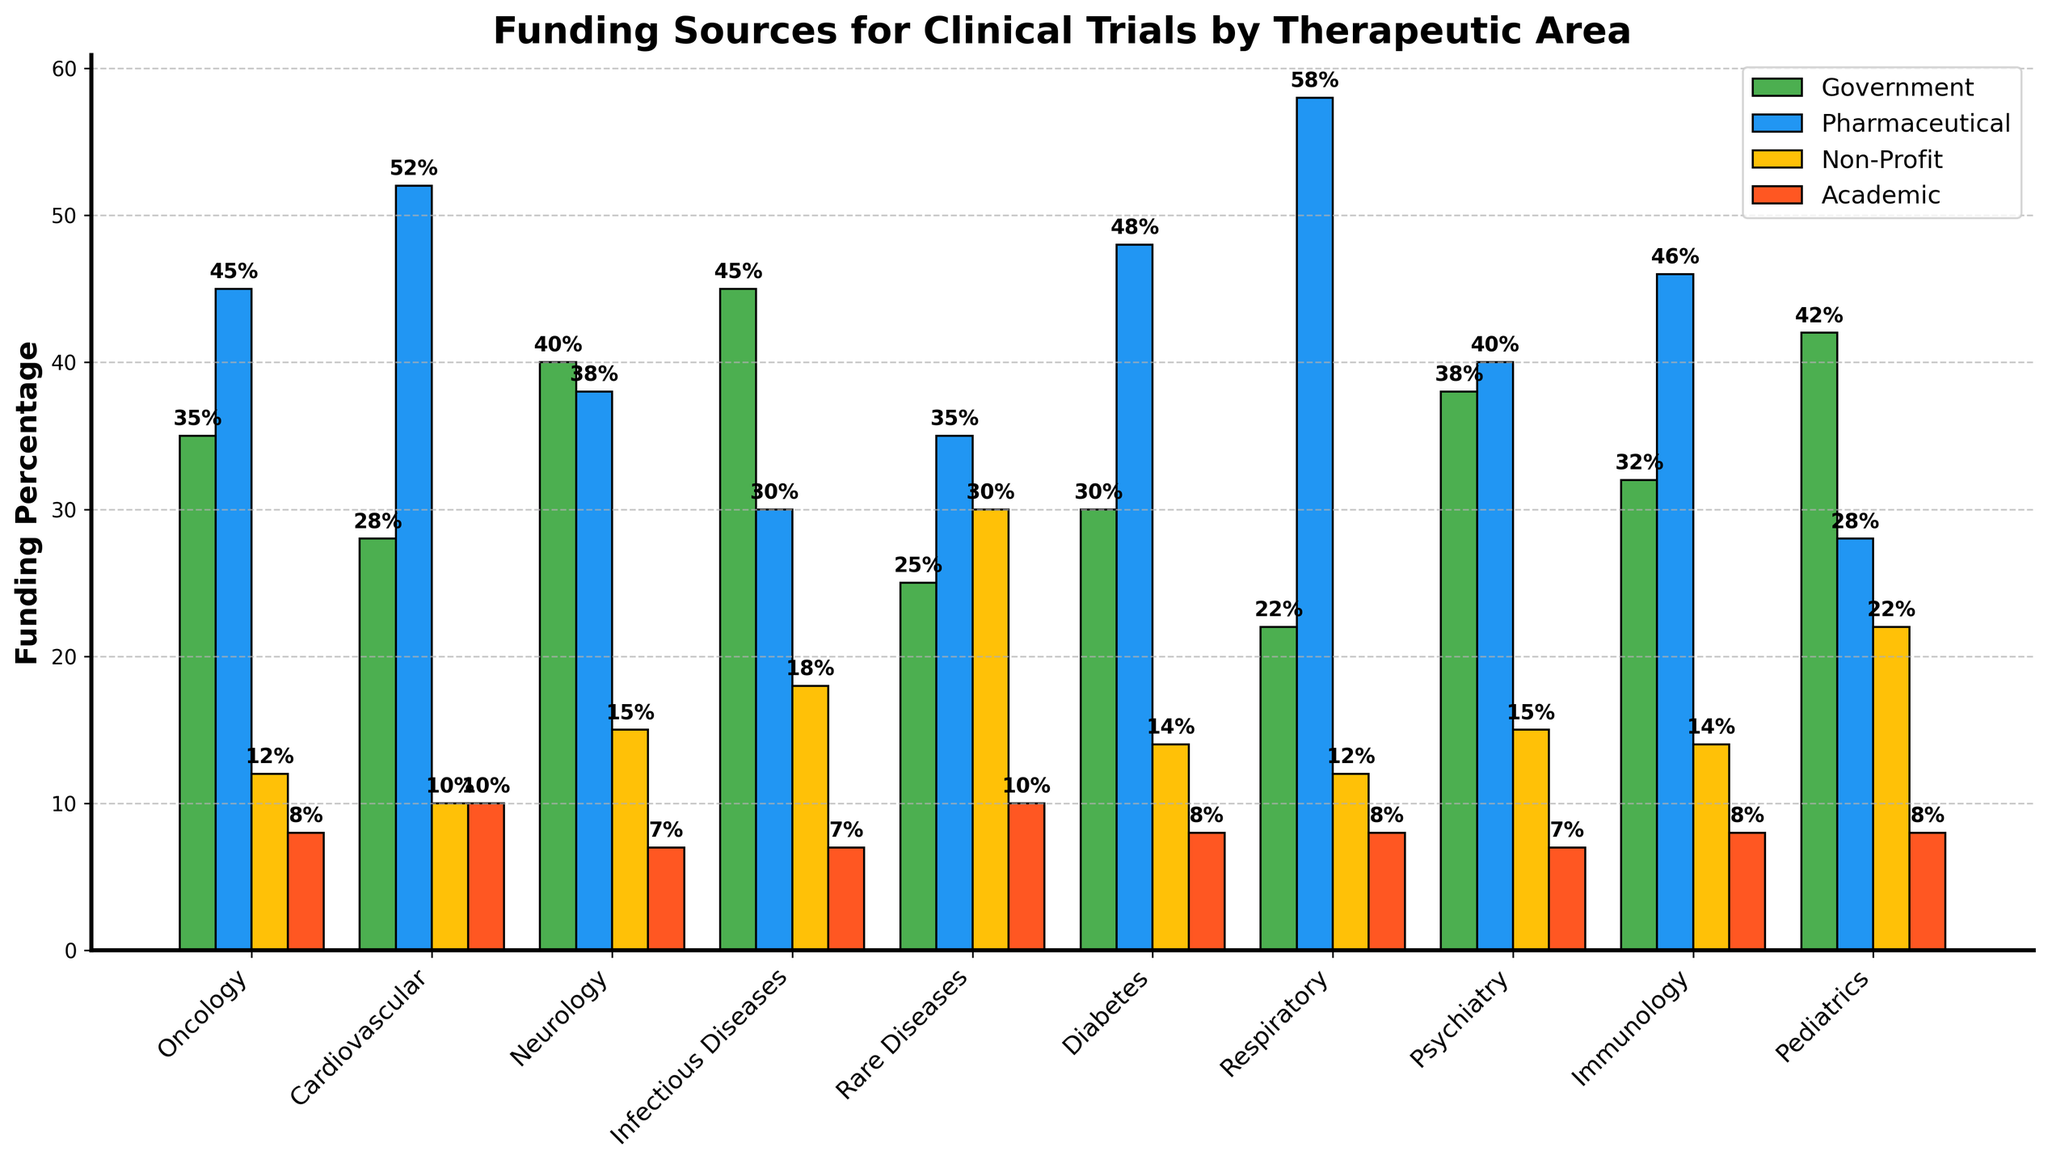Which therapeutic area has the highest percentage of government funding? The bar representing government funding reaches the highest point for Infectious Diseases at 45%.
Answer: Infectious Diseases Which organizations provide the most funding for Cardiovascular clinical trials? For Cardiovascular, the bar representing the Pharmaceutical Industry is the highest at 52%.
Answer: Pharmaceutical Industry Compare the government and academic funding for Pediatrics. Which one is higher? For Pediatrics, government funding is 42%, whereas academic funding is 8%. Since 42% is greater than 8%, government funding is higher.
Answer: Government funding What's the total funding percentage provided by non-profit organizations and academic institutions for Rare Diseases? For Rare Diseases, non-profit funding is 30% and academic funding is 10%. By summing these values: 30% + 10% = 40%.
Answer: 40% For which therapeutic area is the pharmaceutical industry's funding the lowest? The Pharmaceutical funding bar is the shortest for Pediatrics at 28%.
Answer: Pediatrics Which therapeutic area has the most balanced funding distribution across the four sources? For Neurology, the funding percentages are 40% (government), 38% (pharmaceutical), 15% (non-profit), and 7% (academic). This distribution is relatively balanced compared to others.
Answer: Neurology Calculate the average funding percentage provided by academic institutions across all therapeutic areas. Sum all academic funding percentages: 8, 10, 7, 7, 10, 8, 8, 7, 8, 8 -> total = 81. Divide by the number of areas: 81 / 10 = 8.1%
Answer: 8.1% Which therapeutic area receives the highest combined funding from government and non-profit organizations? Calculate the combined percentages and find the maximum: Oncology (35%+12%=47%), Cardiovascular (28%+10%=38%), Neurology (40%+15%=55%), Infectious Diseases (45%+18%=63%), Rare Diseases (25%+30%=55%), Diabetes (30%+14%=44%), Respiratory (22%+12%=34%), Psychiatry (38%+15%=53%), Immunology (32%+14%=46%), Pediatrics (42%+22%=64%). Pediatrics has the highest combined funding at 64%.
Answer: Pediatrics 